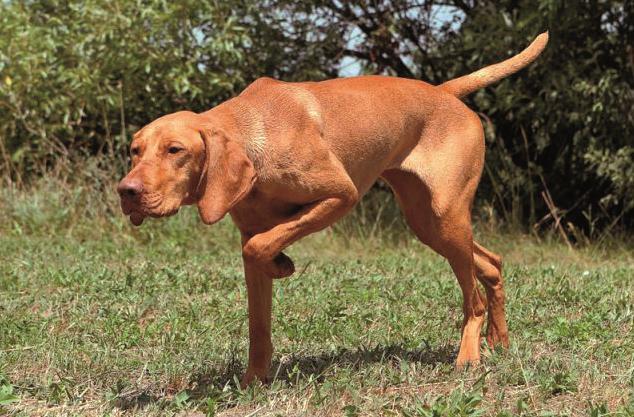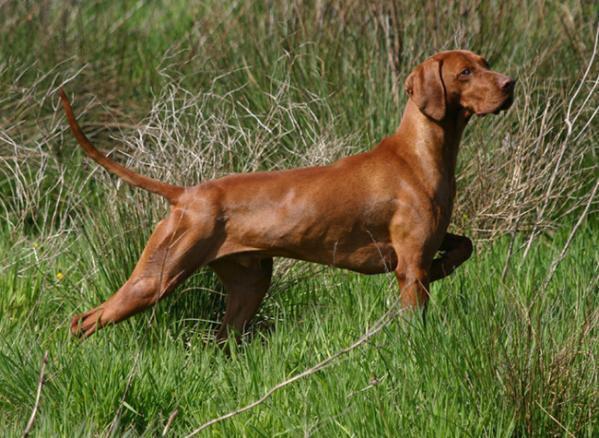The first image is the image on the left, the second image is the image on the right. Examine the images to the left and right. Is the description "The dogs in both images are holding one of their paws up off the ground." accurate? Answer yes or no. Yes. The first image is the image on the left, the second image is the image on the right. Assess this claim about the two images: "The dog in the image on the right is standing with a front leg off the ground.". Correct or not? Answer yes or no. No. 